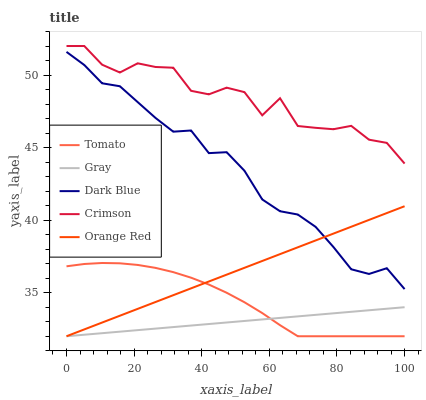Does Gray have the minimum area under the curve?
Answer yes or no. Yes. Does Crimson have the maximum area under the curve?
Answer yes or no. Yes. Does Orange Red have the minimum area under the curve?
Answer yes or no. No. Does Orange Red have the maximum area under the curve?
Answer yes or no. No. Is Orange Red the smoothest?
Answer yes or no. Yes. Is Crimson the roughest?
Answer yes or no. Yes. Is Gray the smoothest?
Answer yes or no. No. Is Gray the roughest?
Answer yes or no. No. Does Tomato have the lowest value?
Answer yes or no. Yes. Does Crimson have the lowest value?
Answer yes or no. No. Does Crimson have the highest value?
Answer yes or no. Yes. Does Orange Red have the highest value?
Answer yes or no. No. Is Tomato less than Crimson?
Answer yes or no. Yes. Is Crimson greater than Dark Blue?
Answer yes or no. Yes. Does Gray intersect Tomato?
Answer yes or no. Yes. Is Gray less than Tomato?
Answer yes or no. No. Is Gray greater than Tomato?
Answer yes or no. No. Does Tomato intersect Crimson?
Answer yes or no. No. 